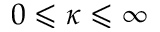Convert formula to latex. <formula><loc_0><loc_0><loc_500><loc_500>0 \leqslant \kappa \leqslant \infty</formula> 